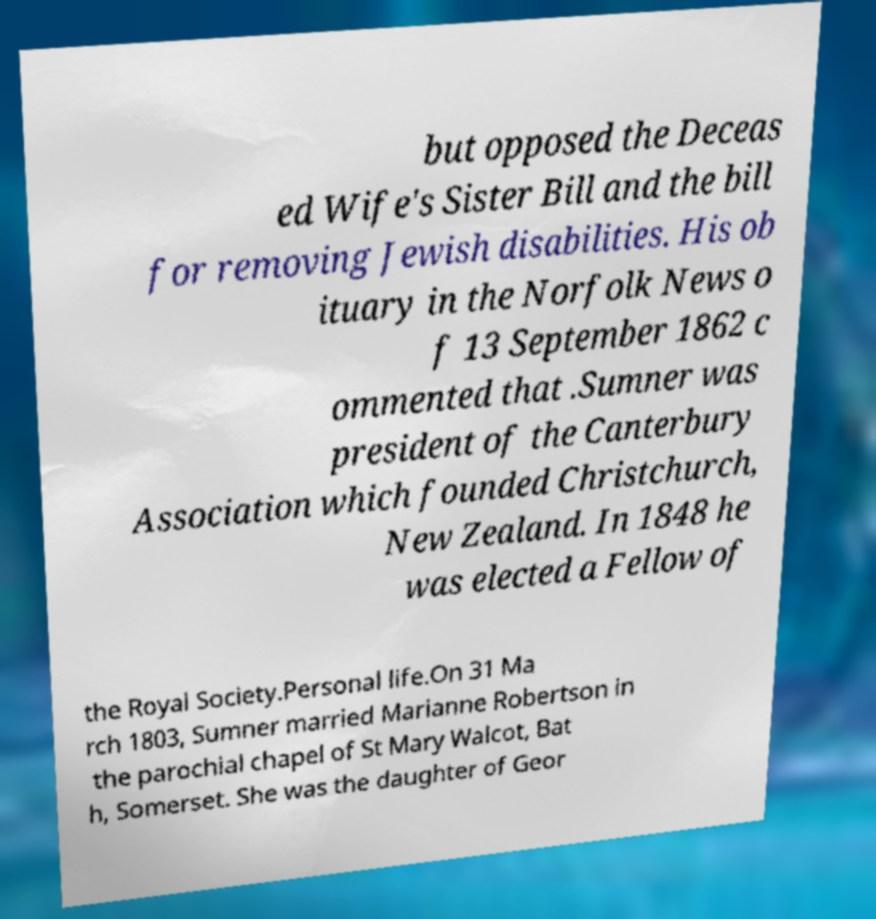Can you read and provide the text displayed in the image?This photo seems to have some interesting text. Can you extract and type it out for me? but opposed the Deceas ed Wife's Sister Bill and the bill for removing Jewish disabilities. His ob ituary in the Norfolk News o f 13 September 1862 c ommented that .Sumner was president of the Canterbury Association which founded Christchurch, New Zealand. In 1848 he was elected a Fellow of the Royal Society.Personal life.On 31 Ma rch 1803, Sumner married Marianne Robertson in the parochial chapel of St Mary Walcot, Bat h, Somerset. She was the daughter of Geor 